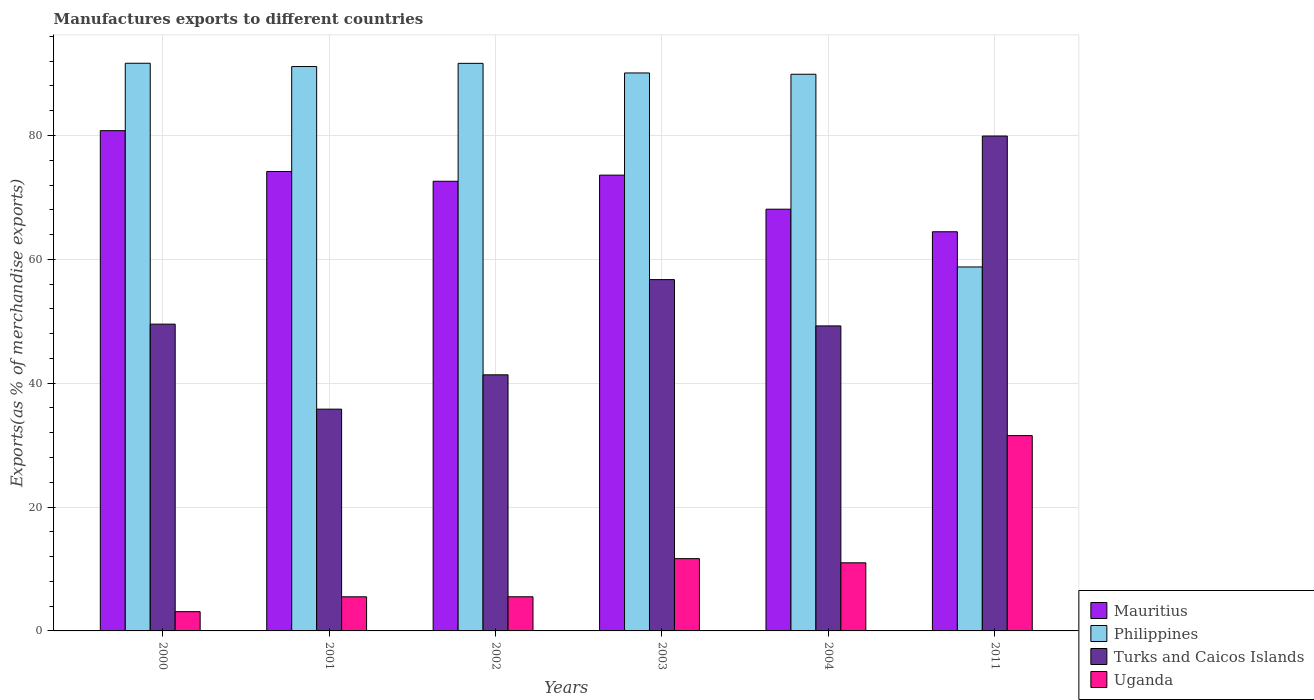Are the number of bars on each tick of the X-axis equal?
Offer a very short reply. Yes. How many bars are there on the 1st tick from the left?
Your response must be concise. 4. How many bars are there on the 5th tick from the right?
Offer a very short reply. 4. In how many cases, is the number of bars for a given year not equal to the number of legend labels?
Offer a terse response. 0. What is the percentage of exports to different countries in Philippines in 2003?
Provide a succinct answer. 90.11. Across all years, what is the maximum percentage of exports to different countries in Turks and Caicos Islands?
Your response must be concise. 79.92. Across all years, what is the minimum percentage of exports to different countries in Philippines?
Provide a short and direct response. 58.78. In which year was the percentage of exports to different countries in Mauritius maximum?
Offer a terse response. 2000. In which year was the percentage of exports to different countries in Philippines minimum?
Give a very brief answer. 2011. What is the total percentage of exports to different countries in Uganda in the graph?
Your answer should be very brief. 68.34. What is the difference between the percentage of exports to different countries in Turks and Caicos Islands in 2002 and that in 2003?
Provide a short and direct response. -15.38. What is the difference between the percentage of exports to different countries in Philippines in 2000 and the percentage of exports to different countries in Turks and Caicos Islands in 2004?
Keep it short and to the point. 42.42. What is the average percentage of exports to different countries in Philippines per year?
Offer a very short reply. 85.54. In the year 2003, what is the difference between the percentage of exports to different countries in Philippines and percentage of exports to different countries in Uganda?
Your response must be concise. 78.43. In how many years, is the percentage of exports to different countries in Uganda greater than 12 %?
Your answer should be very brief. 1. What is the ratio of the percentage of exports to different countries in Mauritius in 2002 to that in 2003?
Your answer should be very brief. 0.99. What is the difference between the highest and the second highest percentage of exports to different countries in Philippines?
Your answer should be compact. 0.01. What is the difference between the highest and the lowest percentage of exports to different countries in Mauritius?
Your answer should be very brief. 16.33. In how many years, is the percentage of exports to different countries in Mauritius greater than the average percentage of exports to different countries in Mauritius taken over all years?
Offer a terse response. 4. Is the sum of the percentage of exports to different countries in Turks and Caicos Islands in 2001 and 2003 greater than the maximum percentage of exports to different countries in Mauritius across all years?
Provide a short and direct response. Yes. Is it the case that in every year, the sum of the percentage of exports to different countries in Mauritius and percentage of exports to different countries in Uganda is greater than the sum of percentage of exports to different countries in Philippines and percentage of exports to different countries in Turks and Caicos Islands?
Offer a very short reply. Yes. What does the 4th bar from the left in 2003 represents?
Provide a short and direct response. Uganda. Is it the case that in every year, the sum of the percentage of exports to different countries in Turks and Caicos Islands and percentage of exports to different countries in Philippines is greater than the percentage of exports to different countries in Mauritius?
Your answer should be very brief. Yes. How many bars are there?
Offer a terse response. 24. Are all the bars in the graph horizontal?
Make the answer very short. No. How many years are there in the graph?
Provide a short and direct response. 6. What is the difference between two consecutive major ticks on the Y-axis?
Provide a short and direct response. 20. Are the values on the major ticks of Y-axis written in scientific E-notation?
Make the answer very short. No. Does the graph contain grids?
Give a very brief answer. Yes. How many legend labels are there?
Offer a very short reply. 4. How are the legend labels stacked?
Provide a short and direct response. Vertical. What is the title of the graph?
Your answer should be very brief. Manufactures exports to different countries. What is the label or title of the Y-axis?
Your answer should be very brief. Exports(as % of merchandise exports). What is the Exports(as % of merchandise exports) in Mauritius in 2000?
Provide a succinct answer. 80.79. What is the Exports(as % of merchandise exports) of Philippines in 2000?
Make the answer very short. 91.67. What is the Exports(as % of merchandise exports) in Turks and Caicos Islands in 2000?
Offer a very short reply. 49.54. What is the Exports(as % of merchandise exports) of Uganda in 2000?
Keep it short and to the point. 3.11. What is the Exports(as % of merchandise exports) of Mauritius in 2001?
Make the answer very short. 74.19. What is the Exports(as % of merchandise exports) in Philippines in 2001?
Your response must be concise. 91.14. What is the Exports(as % of merchandise exports) in Turks and Caicos Islands in 2001?
Provide a short and direct response. 35.81. What is the Exports(as % of merchandise exports) of Uganda in 2001?
Ensure brevity in your answer.  5.51. What is the Exports(as % of merchandise exports) of Mauritius in 2002?
Your answer should be very brief. 72.61. What is the Exports(as % of merchandise exports) of Philippines in 2002?
Provide a succinct answer. 91.66. What is the Exports(as % of merchandise exports) of Turks and Caicos Islands in 2002?
Ensure brevity in your answer.  41.36. What is the Exports(as % of merchandise exports) of Uganda in 2002?
Give a very brief answer. 5.52. What is the Exports(as % of merchandise exports) in Mauritius in 2003?
Give a very brief answer. 73.6. What is the Exports(as % of merchandise exports) in Philippines in 2003?
Keep it short and to the point. 90.11. What is the Exports(as % of merchandise exports) in Turks and Caicos Islands in 2003?
Ensure brevity in your answer.  56.73. What is the Exports(as % of merchandise exports) of Uganda in 2003?
Ensure brevity in your answer.  11.67. What is the Exports(as % of merchandise exports) of Mauritius in 2004?
Ensure brevity in your answer.  68.1. What is the Exports(as % of merchandise exports) of Philippines in 2004?
Offer a terse response. 89.9. What is the Exports(as % of merchandise exports) in Turks and Caicos Islands in 2004?
Provide a short and direct response. 49.25. What is the Exports(as % of merchandise exports) in Uganda in 2004?
Your response must be concise. 11. What is the Exports(as % of merchandise exports) in Mauritius in 2011?
Keep it short and to the point. 64.46. What is the Exports(as % of merchandise exports) in Philippines in 2011?
Provide a short and direct response. 58.78. What is the Exports(as % of merchandise exports) of Turks and Caicos Islands in 2011?
Offer a terse response. 79.92. What is the Exports(as % of merchandise exports) in Uganda in 2011?
Keep it short and to the point. 31.54. Across all years, what is the maximum Exports(as % of merchandise exports) in Mauritius?
Ensure brevity in your answer.  80.79. Across all years, what is the maximum Exports(as % of merchandise exports) in Philippines?
Offer a very short reply. 91.67. Across all years, what is the maximum Exports(as % of merchandise exports) of Turks and Caicos Islands?
Offer a terse response. 79.92. Across all years, what is the maximum Exports(as % of merchandise exports) of Uganda?
Offer a terse response. 31.54. Across all years, what is the minimum Exports(as % of merchandise exports) of Mauritius?
Your response must be concise. 64.46. Across all years, what is the minimum Exports(as % of merchandise exports) of Philippines?
Your answer should be very brief. 58.78. Across all years, what is the minimum Exports(as % of merchandise exports) of Turks and Caicos Islands?
Your response must be concise. 35.81. Across all years, what is the minimum Exports(as % of merchandise exports) in Uganda?
Give a very brief answer. 3.11. What is the total Exports(as % of merchandise exports) in Mauritius in the graph?
Offer a very short reply. 433.76. What is the total Exports(as % of merchandise exports) of Philippines in the graph?
Provide a short and direct response. 513.25. What is the total Exports(as % of merchandise exports) of Turks and Caicos Islands in the graph?
Your response must be concise. 312.62. What is the total Exports(as % of merchandise exports) of Uganda in the graph?
Keep it short and to the point. 68.34. What is the difference between the Exports(as % of merchandise exports) in Mauritius in 2000 and that in 2001?
Give a very brief answer. 6.59. What is the difference between the Exports(as % of merchandise exports) of Philippines in 2000 and that in 2001?
Provide a succinct answer. 0.53. What is the difference between the Exports(as % of merchandise exports) in Turks and Caicos Islands in 2000 and that in 2001?
Keep it short and to the point. 13.73. What is the difference between the Exports(as % of merchandise exports) of Uganda in 2000 and that in 2001?
Keep it short and to the point. -2.4. What is the difference between the Exports(as % of merchandise exports) of Mauritius in 2000 and that in 2002?
Provide a succinct answer. 8.17. What is the difference between the Exports(as % of merchandise exports) of Philippines in 2000 and that in 2002?
Your answer should be very brief. 0.01. What is the difference between the Exports(as % of merchandise exports) of Turks and Caicos Islands in 2000 and that in 2002?
Offer a terse response. 8.19. What is the difference between the Exports(as % of merchandise exports) of Uganda in 2000 and that in 2002?
Keep it short and to the point. -2.41. What is the difference between the Exports(as % of merchandise exports) in Mauritius in 2000 and that in 2003?
Offer a very short reply. 7.18. What is the difference between the Exports(as % of merchandise exports) in Philippines in 2000 and that in 2003?
Your response must be concise. 1.57. What is the difference between the Exports(as % of merchandise exports) of Turks and Caicos Islands in 2000 and that in 2003?
Offer a very short reply. -7.19. What is the difference between the Exports(as % of merchandise exports) of Uganda in 2000 and that in 2003?
Provide a succinct answer. -8.56. What is the difference between the Exports(as % of merchandise exports) of Mauritius in 2000 and that in 2004?
Offer a very short reply. 12.68. What is the difference between the Exports(as % of merchandise exports) in Philippines in 2000 and that in 2004?
Give a very brief answer. 1.77. What is the difference between the Exports(as % of merchandise exports) in Turks and Caicos Islands in 2000 and that in 2004?
Keep it short and to the point. 0.29. What is the difference between the Exports(as % of merchandise exports) of Uganda in 2000 and that in 2004?
Provide a succinct answer. -7.89. What is the difference between the Exports(as % of merchandise exports) of Mauritius in 2000 and that in 2011?
Your answer should be very brief. 16.33. What is the difference between the Exports(as % of merchandise exports) in Philippines in 2000 and that in 2011?
Your answer should be compact. 32.89. What is the difference between the Exports(as % of merchandise exports) in Turks and Caicos Islands in 2000 and that in 2011?
Your response must be concise. -30.38. What is the difference between the Exports(as % of merchandise exports) in Uganda in 2000 and that in 2011?
Provide a succinct answer. -28.43. What is the difference between the Exports(as % of merchandise exports) of Mauritius in 2001 and that in 2002?
Ensure brevity in your answer.  1.58. What is the difference between the Exports(as % of merchandise exports) of Philippines in 2001 and that in 2002?
Make the answer very short. -0.52. What is the difference between the Exports(as % of merchandise exports) in Turks and Caicos Islands in 2001 and that in 2002?
Give a very brief answer. -5.54. What is the difference between the Exports(as % of merchandise exports) of Uganda in 2001 and that in 2002?
Offer a terse response. -0.01. What is the difference between the Exports(as % of merchandise exports) of Mauritius in 2001 and that in 2003?
Give a very brief answer. 0.59. What is the difference between the Exports(as % of merchandise exports) in Philippines in 2001 and that in 2003?
Make the answer very short. 1.04. What is the difference between the Exports(as % of merchandise exports) of Turks and Caicos Islands in 2001 and that in 2003?
Keep it short and to the point. -20.92. What is the difference between the Exports(as % of merchandise exports) of Uganda in 2001 and that in 2003?
Offer a very short reply. -6.16. What is the difference between the Exports(as % of merchandise exports) in Mauritius in 2001 and that in 2004?
Your answer should be compact. 6.09. What is the difference between the Exports(as % of merchandise exports) in Philippines in 2001 and that in 2004?
Your response must be concise. 1.25. What is the difference between the Exports(as % of merchandise exports) in Turks and Caicos Islands in 2001 and that in 2004?
Provide a short and direct response. -13.44. What is the difference between the Exports(as % of merchandise exports) of Uganda in 2001 and that in 2004?
Keep it short and to the point. -5.49. What is the difference between the Exports(as % of merchandise exports) in Mauritius in 2001 and that in 2011?
Your answer should be compact. 9.73. What is the difference between the Exports(as % of merchandise exports) in Philippines in 2001 and that in 2011?
Your response must be concise. 32.36. What is the difference between the Exports(as % of merchandise exports) in Turks and Caicos Islands in 2001 and that in 2011?
Your answer should be very brief. -44.11. What is the difference between the Exports(as % of merchandise exports) in Uganda in 2001 and that in 2011?
Keep it short and to the point. -26.03. What is the difference between the Exports(as % of merchandise exports) in Mauritius in 2002 and that in 2003?
Make the answer very short. -0.99. What is the difference between the Exports(as % of merchandise exports) of Philippines in 2002 and that in 2003?
Offer a terse response. 1.55. What is the difference between the Exports(as % of merchandise exports) of Turks and Caicos Islands in 2002 and that in 2003?
Give a very brief answer. -15.38. What is the difference between the Exports(as % of merchandise exports) of Uganda in 2002 and that in 2003?
Keep it short and to the point. -6.16. What is the difference between the Exports(as % of merchandise exports) of Mauritius in 2002 and that in 2004?
Your answer should be compact. 4.51. What is the difference between the Exports(as % of merchandise exports) of Philippines in 2002 and that in 2004?
Give a very brief answer. 1.76. What is the difference between the Exports(as % of merchandise exports) of Turks and Caicos Islands in 2002 and that in 2004?
Offer a terse response. -7.9. What is the difference between the Exports(as % of merchandise exports) of Uganda in 2002 and that in 2004?
Give a very brief answer. -5.49. What is the difference between the Exports(as % of merchandise exports) of Mauritius in 2002 and that in 2011?
Ensure brevity in your answer.  8.15. What is the difference between the Exports(as % of merchandise exports) in Philippines in 2002 and that in 2011?
Offer a terse response. 32.88. What is the difference between the Exports(as % of merchandise exports) in Turks and Caicos Islands in 2002 and that in 2011?
Make the answer very short. -38.56. What is the difference between the Exports(as % of merchandise exports) of Uganda in 2002 and that in 2011?
Your answer should be compact. -26.02. What is the difference between the Exports(as % of merchandise exports) of Mauritius in 2003 and that in 2004?
Offer a very short reply. 5.5. What is the difference between the Exports(as % of merchandise exports) in Philippines in 2003 and that in 2004?
Provide a succinct answer. 0.21. What is the difference between the Exports(as % of merchandise exports) in Turks and Caicos Islands in 2003 and that in 2004?
Keep it short and to the point. 7.48. What is the difference between the Exports(as % of merchandise exports) in Uganda in 2003 and that in 2004?
Give a very brief answer. 0.67. What is the difference between the Exports(as % of merchandise exports) of Mauritius in 2003 and that in 2011?
Give a very brief answer. 9.14. What is the difference between the Exports(as % of merchandise exports) in Philippines in 2003 and that in 2011?
Ensure brevity in your answer.  31.33. What is the difference between the Exports(as % of merchandise exports) in Turks and Caicos Islands in 2003 and that in 2011?
Give a very brief answer. -23.19. What is the difference between the Exports(as % of merchandise exports) of Uganda in 2003 and that in 2011?
Make the answer very short. -19.87. What is the difference between the Exports(as % of merchandise exports) of Mauritius in 2004 and that in 2011?
Provide a succinct answer. 3.64. What is the difference between the Exports(as % of merchandise exports) in Philippines in 2004 and that in 2011?
Keep it short and to the point. 31.12. What is the difference between the Exports(as % of merchandise exports) in Turks and Caicos Islands in 2004 and that in 2011?
Give a very brief answer. -30.67. What is the difference between the Exports(as % of merchandise exports) of Uganda in 2004 and that in 2011?
Your answer should be very brief. -20.54. What is the difference between the Exports(as % of merchandise exports) in Mauritius in 2000 and the Exports(as % of merchandise exports) in Philippines in 2001?
Give a very brief answer. -10.36. What is the difference between the Exports(as % of merchandise exports) in Mauritius in 2000 and the Exports(as % of merchandise exports) in Turks and Caicos Islands in 2001?
Offer a terse response. 44.97. What is the difference between the Exports(as % of merchandise exports) in Mauritius in 2000 and the Exports(as % of merchandise exports) in Uganda in 2001?
Your response must be concise. 75.28. What is the difference between the Exports(as % of merchandise exports) of Philippines in 2000 and the Exports(as % of merchandise exports) of Turks and Caicos Islands in 2001?
Your answer should be very brief. 55.86. What is the difference between the Exports(as % of merchandise exports) in Philippines in 2000 and the Exports(as % of merchandise exports) in Uganda in 2001?
Keep it short and to the point. 86.16. What is the difference between the Exports(as % of merchandise exports) in Turks and Caicos Islands in 2000 and the Exports(as % of merchandise exports) in Uganda in 2001?
Offer a terse response. 44.03. What is the difference between the Exports(as % of merchandise exports) of Mauritius in 2000 and the Exports(as % of merchandise exports) of Philippines in 2002?
Provide a short and direct response. -10.87. What is the difference between the Exports(as % of merchandise exports) of Mauritius in 2000 and the Exports(as % of merchandise exports) of Turks and Caicos Islands in 2002?
Provide a short and direct response. 39.43. What is the difference between the Exports(as % of merchandise exports) of Mauritius in 2000 and the Exports(as % of merchandise exports) of Uganda in 2002?
Offer a very short reply. 75.27. What is the difference between the Exports(as % of merchandise exports) in Philippines in 2000 and the Exports(as % of merchandise exports) in Turks and Caicos Islands in 2002?
Your answer should be very brief. 50.31. What is the difference between the Exports(as % of merchandise exports) of Philippines in 2000 and the Exports(as % of merchandise exports) of Uganda in 2002?
Your answer should be compact. 86.16. What is the difference between the Exports(as % of merchandise exports) of Turks and Caicos Islands in 2000 and the Exports(as % of merchandise exports) of Uganda in 2002?
Give a very brief answer. 44.03. What is the difference between the Exports(as % of merchandise exports) of Mauritius in 2000 and the Exports(as % of merchandise exports) of Philippines in 2003?
Ensure brevity in your answer.  -9.32. What is the difference between the Exports(as % of merchandise exports) in Mauritius in 2000 and the Exports(as % of merchandise exports) in Turks and Caicos Islands in 2003?
Keep it short and to the point. 24.05. What is the difference between the Exports(as % of merchandise exports) of Mauritius in 2000 and the Exports(as % of merchandise exports) of Uganda in 2003?
Ensure brevity in your answer.  69.12. What is the difference between the Exports(as % of merchandise exports) in Philippines in 2000 and the Exports(as % of merchandise exports) in Turks and Caicos Islands in 2003?
Provide a short and direct response. 34.94. What is the difference between the Exports(as % of merchandise exports) of Philippines in 2000 and the Exports(as % of merchandise exports) of Uganda in 2003?
Provide a succinct answer. 80. What is the difference between the Exports(as % of merchandise exports) of Turks and Caicos Islands in 2000 and the Exports(as % of merchandise exports) of Uganda in 2003?
Your answer should be compact. 37.87. What is the difference between the Exports(as % of merchandise exports) of Mauritius in 2000 and the Exports(as % of merchandise exports) of Philippines in 2004?
Your answer should be very brief. -9.11. What is the difference between the Exports(as % of merchandise exports) in Mauritius in 2000 and the Exports(as % of merchandise exports) in Turks and Caicos Islands in 2004?
Give a very brief answer. 31.53. What is the difference between the Exports(as % of merchandise exports) of Mauritius in 2000 and the Exports(as % of merchandise exports) of Uganda in 2004?
Your answer should be compact. 69.79. What is the difference between the Exports(as % of merchandise exports) in Philippines in 2000 and the Exports(as % of merchandise exports) in Turks and Caicos Islands in 2004?
Your answer should be compact. 42.42. What is the difference between the Exports(as % of merchandise exports) of Philippines in 2000 and the Exports(as % of merchandise exports) of Uganda in 2004?
Your answer should be compact. 80.67. What is the difference between the Exports(as % of merchandise exports) of Turks and Caicos Islands in 2000 and the Exports(as % of merchandise exports) of Uganda in 2004?
Provide a short and direct response. 38.54. What is the difference between the Exports(as % of merchandise exports) in Mauritius in 2000 and the Exports(as % of merchandise exports) in Philippines in 2011?
Your response must be concise. 22.01. What is the difference between the Exports(as % of merchandise exports) of Mauritius in 2000 and the Exports(as % of merchandise exports) of Turks and Caicos Islands in 2011?
Your answer should be compact. 0.86. What is the difference between the Exports(as % of merchandise exports) in Mauritius in 2000 and the Exports(as % of merchandise exports) in Uganda in 2011?
Your response must be concise. 49.25. What is the difference between the Exports(as % of merchandise exports) in Philippines in 2000 and the Exports(as % of merchandise exports) in Turks and Caicos Islands in 2011?
Your answer should be compact. 11.75. What is the difference between the Exports(as % of merchandise exports) in Philippines in 2000 and the Exports(as % of merchandise exports) in Uganda in 2011?
Ensure brevity in your answer.  60.13. What is the difference between the Exports(as % of merchandise exports) in Turks and Caicos Islands in 2000 and the Exports(as % of merchandise exports) in Uganda in 2011?
Offer a terse response. 18. What is the difference between the Exports(as % of merchandise exports) of Mauritius in 2001 and the Exports(as % of merchandise exports) of Philippines in 2002?
Keep it short and to the point. -17.46. What is the difference between the Exports(as % of merchandise exports) of Mauritius in 2001 and the Exports(as % of merchandise exports) of Turks and Caicos Islands in 2002?
Keep it short and to the point. 32.84. What is the difference between the Exports(as % of merchandise exports) in Mauritius in 2001 and the Exports(as % of merchandise exports) in Uganda in 2002?
Your answer should be compact. 68.68. What is the difference between the Exports(as % of merchandise exports) in Philippines in 2001 and the Exports(as % of merchandise exports) in Turks and Caicos Islands in 2002?
Keep it short and to the point. 49.79. What is the difference between the Exports(as % of merchandise exports) in Philippines in 2001 and the Exports(as % of merchandise exports) in Uganda in 2002?
Your response must be concise. 85.63. What is the difference between the Exports(as % of merchandise exports) of Turks and Caicos Islands in 2001 and the Exports(as % of merchandise exports) of Uganda in 2002?
Keep it short and to the point. 30.3. What is the difference between the Exports(as % of merchandise exports) in Mauritius in 2001 and the Exports(as % of merchandise exports) in Philippines in 2003?
Provide a short and direct response. -15.91. What is the difference between the Exports(as % of merchandise exports) in Mauritius in 2001 and the Exports(as % of merchandise exports) in Turks and Caicos Islands in 2003?
Give a very brief answer. 17.46. What is the difference between the Exports(as % of merchandise exports) of Mauritius in 2001 and the Exports(as % of merchandise exports) of Uganda in 2003?
Your answer should be compact. 62.52. What is the difference between the Exports(as % of merchandise exports) of Philippines in 2001 and the Exports(as % of merchandise exports) of Turks and Caicos Islands in 2003?
Your response must be concise. 34.41. What is the difference between the Exports(as % of merchandise exports) of Philippines in 2001 and the Exports(as % of merchandise exports) of Uganda in 2003?
Ensure brevity in your answer.  79.47. What is the difference between the Exports(as % of merchandise exports) in Turks and Caicos Islands in 2001 and the Exports(as % of merchandise exports) in Uganda in 2003?
Ensure brevity in your answer.  24.14. What is the difference between the Exports(as % of merchandise exports) of Mauritius in 2001 and the Exports(as % of merchandise exports) of Philippines in 2004?
Keep it short and to the point. -15.7. What is the difference between the Exports(as % of merchandise exports) of Mauritius in 2001 and the Exports(as % of merchandise exports) of Turks and Caicos Islands in 2004?
Provide a short and direct response. 24.94. What is the difference between the Exports(as % of merchandise exports) in Mauritius in 2001 and the Exports(as % of merchandise exports) in Uganda in 2004?
Offer a very short reply. 63.19. What is the difference between the Exports(as % of merchandise exports) of Philippines in 2001 and the Exports(as % of merchandise exports) of Turks and Caicos Islands in 2004?
Your answer should be compact. 41.89. What is the difference between the Exports(as % of merchandise exports) in Philippines in 2001 and the Exports(as % of merchandise exports) in Uganda in 2004?
Offer a terse response. 80.14. What is the difference between the Exports(as % of merchandise exports) of Turks and Caicos Islands in 2001 and the Exports(as % of merchandise exports) of Uganda in 2004?
Offer a very short reply. 24.81. What is the difference between the Exports(as % of merchandise exports) in Mauritius in 2001 and the Exports(as % of merchandise exports) in Philippines in 2011?
Your answer should be compact. 15.41. What is the difference between the Exports(as % of merchandise exports) of Mauritius in 2001 and the Exports(as % of merchandise exports) of Turks and Caicos Islands in 2011?
Provide a succinct answer. -5.73. What is the difference between the Exports(as % of merchandise exports) in Mauritius in 2001 and the Exports(as % of merchandise exports) in Uganda in 2011?
Offer a very short reply. 42.65. What is the difference between the Exports(as % of merchandise exports) in Philippines in 2001 and the Exports(as % of merchandise exports) in Turks and Caicos Islands in 2011?
Offer a terse response. 11.22. What is the difference between the Exports(as % of merchandise exports) of Philippines in 2001 and the Exports(as % of merchandise exports) of Uganda in 2011?
Your answer should be compact. 59.6. What is the difference between the Exports(as % of merchandise exports) of Turks and Caicos Islands in 2001 and the Exports(as % of merchandise exports) of Uganda in 2011?
Offer a very short reply. 4.27. What is the difference between the Exports(as % of merchandise exports) in Mauritius in 2002 and the Exports(as % of merchandise exports) in Philippines in 2003?
Offer a terse response. -17.49. What is the difference between the Exports(as % of merchandise exports) of Mauritius in 2002 and the Exports(as % of merchandise exports) of Turks and Caicos Islands in 2003?
Offer a very short reply. 15.88. What is the difference between the Exports(as % of merchandise exports) of Mauritius in 2002 and the Exports(as % of merchandise exports) of Uganda in 2003?
Your answer should be compact. 60.94. What is the difference between the Exports(as % of merchandise exports) in Philippines in 2002 and the Exports(as % of merchandise exports) in Turks and Caicos Islands in 2003?
Make the answer very short. 34.92. What is the difference between the Exports(as % of merchandise exports) of Philippines in 2002 and the Exports(as % of merchandise exports) of Uganda in 2003?
Provide a short and direct response. 79.99. What is the difference between the Exports(as % of merchandise exports) of Turks and Caicos Islands in 2002 and the Exports(as % of merchandise exports) of Uganda in 2003?
Provide a succinct answer. 29.69. What is the difference between the Exports(as % of merchandise exports) in Mauritius in 2002 and the Exports(as % of merchandise exports) in Philippines in 2004?
Keep it short and to the point. -17.28. What is the difference between the Exports(as % of merchandise exports) in Mauritius in 2002 and the Exports(as % of merchandise exports) in Turks and Caicos Islands in 2004?
Give a very brief answer. 23.36. What is the difference between the Exports(as % of merchandise exports) of Mauritius in 2002 and the Exports(as % of merchandise exports) of Uganda in 2004?
Your answer should be compact. 61.61. What is the difference between the Exports(as % of merchandise exports) of Philippines in 2002 and the Exports(as % of merchandise exports) of Turks and Caicos Islands in 2004?
Provide a succinct answer. 42.4. What is the difference between the Exports(as % of merchandise exports) in Philippines in 2002 and the Exports(as % of merchandise exports) in Uganda in 2004?
Your answer should be compact. 80.66. What is the difference between the Exports(as % of merchandise exports) in Turks and Caicos Islands in 2002 and the Exports(as % of merchandise exports) in Uganda in 2004?
Offer a terse response. 30.36. What is the difference between the Exports(as % of merchandise exports) of Mauritius in 2002 and the Exports(as % of merchandise exports) of Philippines in 2011?
Offer a terse response. 13.84. What is the difference between the Exports(as % of merchandise exports) in Mauritius in 2002 and the Exports(as % of merchandise exports) in Turks and Caicos Islands in 2011?
Ensure brevity in your answer.  -7.31. What is the difference between the Exports(as % of merchandise exports) of Mauritius in 2002 and the Exports(as % of merchandise exports) of Uganda in 2011?
Offer a very short reply. 41.08. What is the difference between the Exports(as % of merchandise exports) in Philippines in 2002 and the Exports(as % of merchandise exports) in Turks and Caicos Islands in 2011?
Your response must be concise. 11.74. What is the difference between the Exports(as % of merchandise exports) in Philippines in 2002 and the Exports(as % of merchandise exports) in Uganda in 2011?
Offer a terse response. 60.12. What is the difference between the Exports(as % of merchandise exports) of Turks and Caicos Islands in 2002 and the Exports(as % of merchandise exports) of Uganda in 2011?
Make the answer very short. 9.82. What is the difference between the Exports(as % of merchandise exports) in Mauritius in 2003 and the Exports(as % of merchandise exports) in Philippines in 2004?
Your response must be concise. -16.29. What is the difference between the Exports(as % of merchandise exports) in Mauritius in 2003 and the Exports(as % of merchandise exports) in Turks and Caicos Islands in 2004?
Offer a very short reply. 24.35. What is the difference between the Exports(as % of merchandise exports) of Mauritius in 2003 and the Exports(as % of merchandise exports) of Uganda in 2004?
Give a very brief answer. 62.6. What is the difference between the Exports(as % of merchandise exports) of Philippines in 2003 and the Exports(as % of merchandise exports) of Turks and Caicos Islands in 2004?
Give a very brief answer. 40.85. What is the difference between the Exports(as % of merchandise exports) in Philippines in 2003 and the Exports(as % of merchandise exports) in Uganda in 2004?
Offer a very short reply. 79.1. What is the difference between the Exports(as % of merchandise exports) of Turks and Caicos Islands in 2003 and the Exports(as % of merchandise exports) of Uganda in 2004?
Provide a short and direct response. 45.73. What is the difference between the Exports(as % of merchandise exports) in Mauritius in 2003 and the Exports(as % of merchandise exports) in Philippines in 2011?
Your answer should be very brief. 14.83. What is the difference between the Exports(as % of merchandise exports) in Mauritius in 2003 and the Exports(as % of merchandise exports) in Turks and Caicos Islands in 2011?
Keep it short and to the point. -6.32. What is the difference between the Exports(as % of merchandise exports) in Mauritius in 2003 and the Exports(as % of merchandise exports) in Uganda in 2011?
Your answer should be very brief. 42.06. What is the difference between the Exports(as % of merchandise exports) of Philippines in 2003 and the Exports(as % of merchandise exports) of Turks and Caicos Islands in 2011?
Provide a short and direct response. 10.18. What is the difference between the Exports(as % of merchandise exports) in Philippines in 2003 and the Exports(as % of merchandise exports) in Uganda in 2011?
Your response must be concise. 58.57. What is the difference between the Exports(as % of merchandise exports) of Turks and Caicos Islands in 2003 and the Exports(as % of merchandise exports) of Uganda in 2011?
Ensure brevity in your answer.  25.19. What is the difference between the Exports(as % of merchandise exports) of Mauritius in 2004 and the Exports(as % of merchandise exports) of Philippines in 2011?
Ensure brevity in your answer.  9.33. What is the difference between the Exports(as % of merchandise exports) in Mauritius in 2004 and the Exports(as % of merchandise exports) in Turks and Caicos Islands in 2011?
Your answer should be compact. -11.82. What is the difference between the Exports(as % of merchandise exports) of Mauritius in 2004 and the Exports(as % of merchandise exports) of Uganda in 2011?
Give a very brief answer. 36.56. What is the difference between the Exports(as % of merchandise exports) of Philippines in 2004 and the Exports(as % of merchandise exports) of Turks and Caicos Islands in 2011?
Provide a short and direct response. 9.98. What is the difference between the Exports(as % of merchandise exports) in Philippines in 2004 and the Exports(as % of merchandise exports) in Uganda in 2011?
Ensure brevity in your answer.  58.36. What is the difference between the Exports(as % of merchandise exports) of Turks and Caicos Islands in 2004 and the Exports(as % of merchandise exports) of Uganda in 2011?
Offer a very short reply. 17.71. What is the average Exports(as % of merchandise exports) of Mauritius per year?
Your response must be concise. 72.29. What is the average Exports(as % of merchandise exports) in Philippines per year?
Offer a very short reply. 85.54. What is the average Exports(as % of merchandise exports) in Turks and Caicos Islands per year?
Offer a terse response. 52.1. What is the average Exports(as % of merchandise exports) of Uganda per year?
Give a very brief answer. 11.39. In the year 2000, what is the difference between the Exports(as % of merchandise exports) in Mauritius and Exports(as % of merchandise exports) in Philippines?
Ensure brevity in your answer.  -10.89. In the year 2000, what is the difference between the Exports(as % of merchandise exports) of Mauritius and Exports(as % of merchandise exports) of Turks and Caicos Islands?
Give a very brief answer. 31.24. In the year 2000, what is the difference between the Exports(as % of merchandise exports) in Mauritius and Exports(as % of merchandise exports) in Uganda?
Ensure brevity in your answer.  77.68. In the year 2000, what is the difference between the Exports(as % of merchandise exports) in Philippines and Exports(as % of merchandise exports) in Turks and Caicos Islands?
Give a very brief answer. 42.13. In the year 2000, what is the difference between the Exports(as % of merchandise exports) of Philippines and Exports(as % of merchandise exports) of Uganda?
Offer a very short reply. 88.56. In the year 2000, what is the difference between the Exports(as % of merchandise exports) of Turks and Caicos Islands and Exports(as % of merchandise exports) of Uganda?
Offer a very short reply. 46.43. In the year 2001, what is the difference between the Exports(as % of merchandise exports) in Mauritius and Exports(as % of merchandise exports) in Philippines?
Provide a succinct answer. -16.95. In the year 2001, what is the difference between the Exports(as % of merchandise exports) in Mauritius and Exports(as % of merchandise exports) in Turks and Caicos Islands?
Give a very brief answer. 38.38. In the year 2001, what is the difference between the Exports(as % of merchandise exports) in Mauritius and Exports(as % of merchandise exports) in Uganda?
Your response must be concise. 68.68. In the year 2001, what is the difference between the Exports(as % of merchandise exports) of Philippines and Exports(as % of merchandise exports) of Turks and Caicos Islands?
Provide a succinct answer. 55.33. In the year 2001, what is the difference between the Exports(as % of merchandise exports) in Philippines and Exports(as % of merchandise exports) in Uganda?
Make the answer very short. 85.63. In the year 2001, what is the difference between the Exports(as % of merchandise exports) in Turks and Caicos Islands and Exports(as % of merchandise exports) in Uganda?
Your answer should be very brief. 30.3. In the year 2002, what is the difference between the Exports(as % of merchandise exports) of Mauritius and Exports(as % of merchandise exports) of Philippines?
Ensure brevity in your answer.  -19.04. In the year 2002, what is the difference between the Exports(as % of merchandise exports) of Mauritius and Exports(as % of merchandise exports) of Turks and Caicos Islands?
Offer a very short reply. 31.26. In the year 2002, what is the difference between the Exports(as % of merchandise exports) of Mauritius and Exports(as % of merchandise exports) of Uganda?
Ensure brevity in your answer.  67.1. In the year 2002, what is the difference between the Exports(as % of merchandise exports) in Philippines and Exports(as % of merchandise exports) in Turks and Caicos Islands?
Provide a succinct answer. 50.3. In the year 2002, what is the difference between the Exports(as % of merchandise exports) of Philippines and Exports(as % of merchandise exports) of Uganda?
Your answer should be compact. 86.14. In the year 2002, what is the difference between the Exports(as % of merchandise exports) of Turks and Caicos Islands and Exports(as % of merchandise exports) of Uganda?
Give a very brief answer. 35.84. In the year 2003, what is the difference between the Exports(as % of merchandise exports) in Mauritius and Exports(as % of merchandise exports) in Philippines?
Give a very brief answer. -16.5. In the year 2003, what is the difference between the Exports(as % of merchandise exports) of Mauritius and Exports(as % of merchandise exports) of Turks and Caicos Islands?
Offer a very short reply. 16.87. In the year 2003, what is the difference between the Exports(as % of merchandise exports) of Mauritius and Exports(as % of merchandise exports) of Uganda?
Your answer should be very brief. 61.93. In the year 2003, what is the difference between the Exports(as % of merchandise exports) in Philippines and Exports(as % of merchandise exports) in Turks and Caicos Islands?
Your answer should be very brief. 33.37. In the year 2003, what is the difference between the Exports(as % of merchandise exports) in Philippines and Exports(as % of merchandise exports) in Uganda?
Make the answer very short. 78.43. In the year 2003, what is the difference between the Exports(as % of merchandise exports) of Turks and Caicos Islands and Exports(as % of merchandise exports) of Uganda?
Offer a terse response. 45.06. In the year 2004, what is the difference between the Exports(as % of merchandise exports) of Mauritius and Exports(as % of merchandise exports) of Philippines?
Your response must be concise. -21.79. In the year 2004, what is the difference between the Exports(as % of merchandise exports) in Mauritius and Exports(as % of merchandise exports) in Turks and Caicos Islands?
Ensure brevity in your answer.  18.85. In the year 2004, what is the difference between the Exports(as % of merchandise exports) of Mauritius and Exports(as % of merchandise exports) of Uganda?
Your answer should be very brief. 57.1. In the year 2004, what is the difference between the Exports(as % of merchandise exports) of Philippines and Exports(as % of merchandise exports) of Turks and Caicos Islands?
Your answer should be very brief. 40.64. In the year 2004, what is the difference between the Exports(as % of merchandise exports) in Philippines and Exports(as % of merchandise exports) in Uganda?
Your answer should be compact. 78.9. In the year 2004, what is the difference between the Exports(as % of merchandise exports) of Turks and Caicos Islands and Exports(as % of merchandise exports) of Uganda?
Provide a succinct answer. 38.25. In the year 2011, what is the difference between the Exports(as % of merchandise exports) in Mauritius and Exports(as % of merchandise exports) in Philippines?
Make the answer very short. 5.68. In the year 2011, what is the difference between the Exports(as % of merchandise exports) of Mauritius and Exports(as % of merchandise exports) of Turks and Caicos Islands?
Your answer should be compact. -15.46. In the year 2011, what is the difference between the Exports(as % of merchandise exports) in Mauritius and Exports(as % of merchandise exports) in Uganda?
Offer a very short reply. 32.92. In the year 2011, what is the difference between the Exports(as % of merchandise exports) of Philippines and Exports(as % of merchandise exports) of Turks and Caicos Islands?
Offer a very short reply. -21.14. In the year 2011, what is the difference between the Exports(as % of merchandise exports) in Philippines and Exports(as % of merchandise exports) in Uganda?
Your answer should be very brief. 27.24. In the year 2011, what is the difference between the Exports(as % of merchandise exports) in Turks and Caicos Islands and Exports(as % of merchandise exports) in Uganda?
Your answer should be compact. 48.38. What is the ratio of the Exports(as % of merchandise exports) in Mauritius in 2000 to that in 2001?
Provide a short and direct response. 1.09. What is the ratio of the Exports(as % of merchandise exports) of Turks and Caicos Islands in 2000 to that in 2001?
Your response must be concise. 1.38. What is the ratio of the Exports(as % of merchandise exports) in Uganda in 2000 to that in 2001?
Your answer should be compact. 0.56. What is the ratio of the Exports(as % of merchandise exports) of Mauritius in 2000 to that in 2002?
Make the answer very short. 1.11. What is the ratio of the Exports(as % of merchandise exports) of Philippines in 2000 to that in 2002?
Provide a succinct answer. 1. What is the ratio of the Exports(as % of merchandise exports) of Turks and Caicos Islands in 2000 to that in 2002?
Make the answer very short. 1.2. What is the ratio of the Exports(as % of merchandise exports) in Uganda in 2000 to that in 2002?
Offer a terse response. 0.56. What is the ratio of the Exports(as % of merchandise exports) of Mauritius in 2000 to that in 2003?
Make the answer very short. 1.1. What is the ratio of the Exports(as % of merchandise exports) in Philippines in 2000 to that in 2003?
Provide a short and direct response. 1.02. What is the ratio of the Exports(as % of merchandise exports) in Turks and Caicos Islands in 2000 to that in 2003?
Your answer should be very brief. 0.87. What is the ratio of the Exports(as % of merchandise exports) of Uganda in 2000 to that in 2003?
Make the answer very short. 0.27. What is the ratio of the Exports(as % of merchandise exports) of Mauritius in 2000 to that in 2004?
Your answer should be compact. 1.19. What is the ratio of the Exports(as % of merchandise exports) in Philippines in 2000 to that in 2004?
Your response must be concise. 1.02. What is the ratio of the Exports(as % of merchandise exports) in Turks and Caicos Islands in 2000 to that in 2004?
Your answer should be compact. 1.01. What is the ratio of the Exports(as % of merchandise exports) of Uganda in 2000 to that in 2004?
Offer a terse response. 0.28. What is the ratio of the Exports(as % of merchandise exports) in Mauritius in 2000 to that in 2011?
Offer a very short reply. 1.25. What is the ratio of the Exports(as % of merchandise exports) of Philippines in 2000 to that in 2011?
Your answer should be very brief. 1.56. What is the ratio of the Exports(as % of merchandise exports) in Turks and Caicos Islands in 2000 to that in 2011?
Your answer should be very brief. 0.62. What is the ratio of the Exports(as % of merchandise exports) of Uganda in 2000 to that in 2011?
Make the answer very short. 0.1. What is the ratio of the Exports(as % of merchandise exports) in Mauritius in 2001 to that in 2002?
Keep it short and to the point. 1.02. What is the ratio of the Exports(as % of merchandise exports) in Turks and Caicos Islands in 2001 to that in 2002?
Your answer should be very brief. 0.87. What is the ratio of the Exports(as % of merchandise exports) in Uganda in 2001 to that in 2002?
Keep it short and to the point. 1. What is the ratio of the Exports(as % of merchandise exports) in Mauritius in 2001 to that in 2003?
Ensure brevity in your answer.  1.01. What is the ratio of the Exports(as % of merchandise exports) of Philippines in 2001 to that in 2003?
Provide a succinct answer. 1.01. What is the ratio of the Exports(as % of merchandise exports) in Turks and Caicos Islands in 2001 to that in 2003?
Provide a succinct answer. 0.63. What is the ratio of the Exports(as % of merchandise exports) in Uganda in 2001 to that in 2003?
Ensure brevity in your answer.  0.47. What is the ratio of the Exports(as % of merchandise exports) in Mauritius in 2001 to that in 2004?
Your response must be concise. 1.09. What is the ratio of the Exports(as % of merchandise exports) in Philippines in 2001 to that in 2004?
Ensure brevity in your answer.  1.01. What is the ratio of the Exports(as % of merchandise exports) of Turks and Caicos Islands in 2001 to that in 2004?
Your answer should be compact. 0.73. What is the ratio of the Exports(as % of merchandise exports) in Uganda in 2001 to that in 2004?
Your answer should be compact. 0.5. What is the ratio of the Exports(as % of merchandise exports) in Mauritius in 2001 to that in 2011?
Your response must be concise. 1.15. What is the ratio of the Exports(as % of merchandise exports) in Philippines in 2001 to that in 2011?
Offer a very short reply. 1.55. What is the ratio of the Exports(as % of merchandise exports) in Turks and Caicos Islands in 2001 to that in 2011?
Your answer should be very brief. 0.45. What is the ratio of the Exports(as % of merchandise exports) in Uganda in 2001 to that in 2011?
Offer a terse response. 0.17. What is the ratio of the Exports(as % of merchandise exports) of Mauritius in 2002 to that in 2003?
Your response must be concise. 0.99. What is the ratio of the Exports(as % of merchandise exports) of Philippines in 2002 to that in 2003?
Ensure brevity in your answer.  1.02. What is the ratio of the Exports(as % of merchandise exports) of Turks and Caicos Islands in 2002 to that in 2003?
Provide a short and direct response. 0.73. What is the ratio of the Exports(as % of merchandise exports) in Uganda in 2002 to that in 2003?
Ensure brevity in your answer.  0.47. What is the ratio of the Exports(as % of merchandise exports) in Mauritius in 2002 to that in 2004?
Offer a very short reply. 1.07. What is the ratio of the Exports(as % of merchandise exports) of Philippines in 2002 to that in 2004?
Provide a short and direct response. 1.02. What is the ratio of the Exports(as % of merchandise exports) of Turks and Caicos Islands in 2002 to that in 2004?
Give a very brief answer. 0.84. What is the ratio of the Exports(as % of merchandise exports) in Uganda in 2002 to that in 2004?
Offer a very short reply. 0.5. What is the ratio of the Exports(as % of merchandise exports) of Mauritius in 2002 to that in 2011?
Your response must be concise. 1.13. What is the ratio of the Exports(as % of merchandise exports) of Philippines in 2002 to that in 2011?
Offer a very short reply. 1.56. What is the ratio of the Exports(as % of merchandise exports) of Turks and Caicos Islands in 2002 to that in 2011?
Offer a very short reply. 0.52. What is the ratio of the Exports(as % of merchandise exports) in Uganda in 2002 to that in 2011?
Offer a very short reply. 0.17. What is the ratio of the Exports(as % of merchandise exports) of Mauritius in 2003 to that in 2004?
Provide a short and direct response. 1.08. What is the ratio of the Exports(as % of merchandise exports) in Turks and Caicos Islands in 2003 to that in 2004?
Provide a succinct answer. 1.15. What is the ratio of the Exports(as % of merchandise exports) in Uganda in 2003 to that in 2004?
Provide a short and direct response. 1.06. What is the ratio of the Exports(as % of merchandise exports) of Mauritius in 2003 to that in 2011?
Your response must be concise. 1.14. What is the ratio of the Exports(as % of merchandise exports) of Philippines in 2003 to that in 2011?
Keep it short and to the point. 1.53. What is the ratio of the Exports(as % of merchandise exports) of Turks and Caicos Islands in 2003 to that in 2011?
Ensure brevity in your answer.  0.71. What is the ratio of the Exports(as % of merchandise exports) in Uganda in 2003 to that in 2011?
Keep it short and to the point. 0.37. What is the ratio of the Exports(as % of merchandise exports) of Mauritius in 2004 to that in 2011?
Provide a succinct answer. 1.06. What is the ratio of the Exports(as % of merchandise exports) in Philippines in 2004 to that in 2011?
Provide a short and direct response. 1.53. What is the ratio of the Exports(as % of merchandise exports) in Turks and Caicos Islands in 2004 to that in 2011?
Provide a succinct answer. 0.62. What is the ratio of the Exports(as % of merchandise exports) in Uganda in 2004 to that in 2011?
Provide a short and direct response. 0.35. What is the difference between the highest and the second highest Exports(as % of merchandise exports) in Mauritius?
Provide a succinct answer. 6.59. What is the difference between the highest and the second highest Exports(as % of merchandise exports) of Philippines?
Offer a terse response. 0.01. What is the difference between the highest and the second highest Exports(as % of merchandise exports) of Turks and Caicos Islands?
Make the answer very short. 23.19. What is the difference between the highest and the second highest Exports(as % of merchandise exports) of Uganda?
Your answer should be very brief. 19.87. What is the difference between the highest and the lowest Exports(as % of merchandise exports) of Mauritius?
Your answer should be compact. 16.33. What is the difference between the highest and the lowest Exports(as % of merchandise exports) of Philippines?
Keep it short and to the point. 32.89. What is the difference between the highest and the lowest Exports(as % of merchandise exports) of Turks and Caicos Islands?
Your response must be concise. 44.11. What is the difference between the highest and the lowest Exports(as % of merchandise exports) in Uganda?
Make the answer very short. 28.43. 